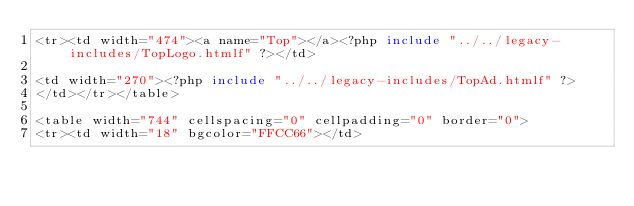<code> <loc_0><loc_0><loc_500><loc_500><_PHP_><tr><td width="474"><a name="Top"></a><?php include "../../legacy-includes/TopLogo.htmlf" ?></td>

<td width="270"><?php include "../../legacy-includes/TopAd.htmlf" ?>
</td></tr></table>

<table width="744" cellspacing="0" cellpadding="0" border="0">
<tr><td width="18" bgcolor="FFCC66"></td>
</code> 